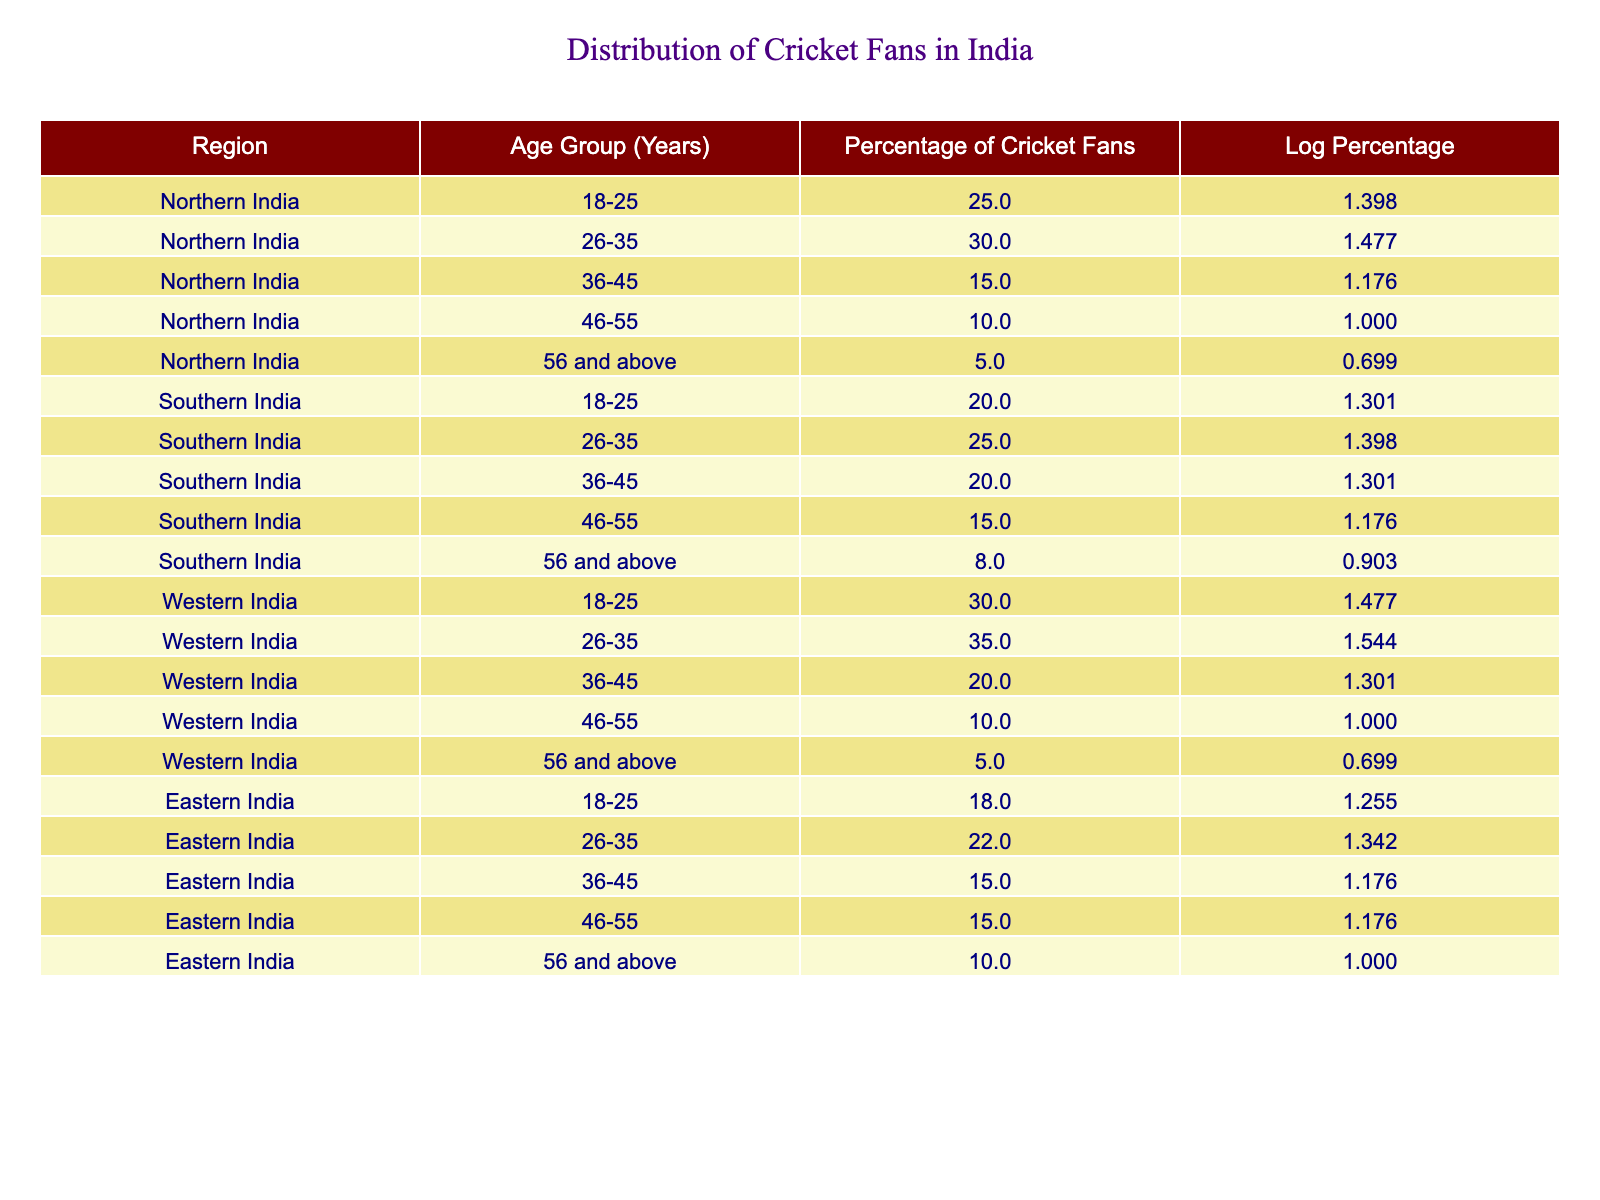What is the percentage of cricket fans aged 26-35 in Western India? According to the table, the percentage of cricket fans aged 26-35 in Western India is directly listed under the corresponding row, which shows a value of 35.0%.
Answer: 35.0% What is the total percentage of cricket fans aged 18-25 across all regions? To find this, we need to sum the percentages for the age group 18-25 from all regions: Northern India (25.0) + Southern India (20.0) + Western India (30.0) + Eastern India (18.0) = 93.0%.
Answer: 93.0% Are there more cricket fans in the age group 36-45 in Southern India compared to Northern India? In Southern India, the percentage of cricket fans aged 36-45 is 20.0%, while in Northern India it is 15.0%. Since 20.0% is greater than 15.0%, the answer is yes.
Answer: Yes What is the average percentage of cricket fans for the age group 46-55 across all regions? The percentages for the age group 46-55 are as follows: Northern India (10.0), Southern India (15.0), Western India (10.0), Eastern India (15.0). To find the average, we add these values (10 + 15 + 10 + 15 = 50) and divide by 4 (50/4 = 12.5).
Answer: 12.5 In which region is there the smallest percentage of cricket fans aged 56 and above? The percentages for the age group 56 and above are as follows: Northern India (5.0), Southern India (8.0), Western India (5.0), Eastern India (10.0). The smallest percentage among these is 5.0%, which corresponds to both Northern and Western India.
Answer: Northern and Western India What percentage of cricket fans aged 26-35 is there in Eastern India? The table indicates that the percentage of cricket fans aged 26-35 in Eastern India is 22.0%, which is directly stated in the relevant row.
Answer: 22.0% What is the difference in percentages of cricket fans aged 36-45 between Western and Eastern India? In Western India, the percentage of cricket fans aged 36-45 is 20.0%, while in Eastern India, it is 15.0%. To find the difference, we subtract: 20.0 - 15.0 = 5.0%.
Answer: 5.0% Is the percentage of cricket fans in the age group 56 and above higher in Southern India compared to Northern India? The percentage in Southern India is 8.0%, while in Northern India it is 5.0%. Since 8.0% is greater than 5.0%, the answer is yes.
Answer: Yes 